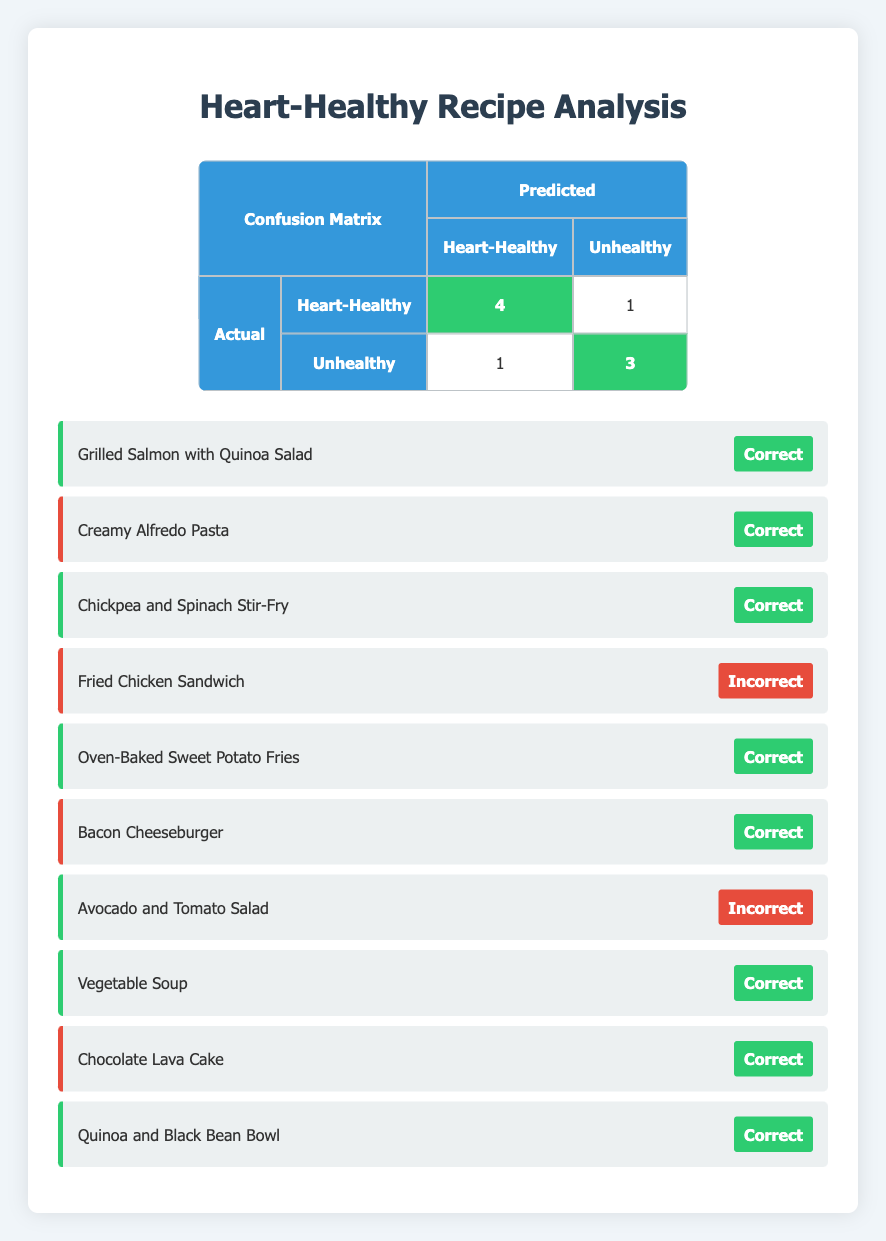What is the total number of heart-healthy recipes? There are 4 heart-healthy recipes listed in the table: Grilled Salmon with Quinoa Salad, Chickpea and Spinach Stir-Fry, Oven-Baked Sweet Potato Fries, and Vegetable Soup.
Answer: 4 How many unhealthy recipes were correctly classified? The table shows 3 unhealthy recipes that were predicted as unhealthy: Creamy Alfredo Pasta, Bacon Cheeseburger, and Chocolate Lava Cake.
Answer: 3 What is the total number of recipes analyzed? The total number of recipes analyzed is 10. This can be confirmed by counting all the entries listed in the table.
Answer: 10 Is the Avocado and Tomato Salad classified correctly? The table indicates that Avocado and Tomato Salad was classified as unhealthy, but its actual classification is heart-healthy, indicating it was classified incorrectly.
Answer: No What is the ratio of correctly classified heart-healthy recipes to incorrectly classified ones? There are 4 correctly classified heart-healthy recipes and 1 incorrectly classified (Avocado and Tomato Salad), making the ratio 4:1.
Answer: 4:1 How many total recipes were predicted to be heart-healthy? The table shows that 5 recipes were predicted to be heart-healthy: Grilled Salmon with Quinoa Salad, Chickpea and Spinach Stir-Fry, Oven-Baked Sweet Potato Fries, Vegetable Soup, and Avocado and Tomato Salad.
Answer: 5 What is the sum of correctly classified and incorrectly classified unhealthy recipes? There are 3 correctly classified unhealthy recipes and 1 incorrectly classified one (Fried Chicken Sandwich), summing them yields 4.
Answer: 4 Which recipe was the only heart-healthy one predicted as unhealthy? The recipe listed as heart-healthy but predicted to be unhealthy is Avocado and Tomato Salad. This can be confirmed by checking the rows in the table.
Answer: Avocado and Tomato Salad How many total incorrect predictions were made? There were 2 incorrect predictions in total: Fried Chicken Sandwich (predicted as heart-healthy when it was unhealthy) and Avocado and Tomato Salad (predicted as unhealthy when it was heart-healthy).
Answer: 2 